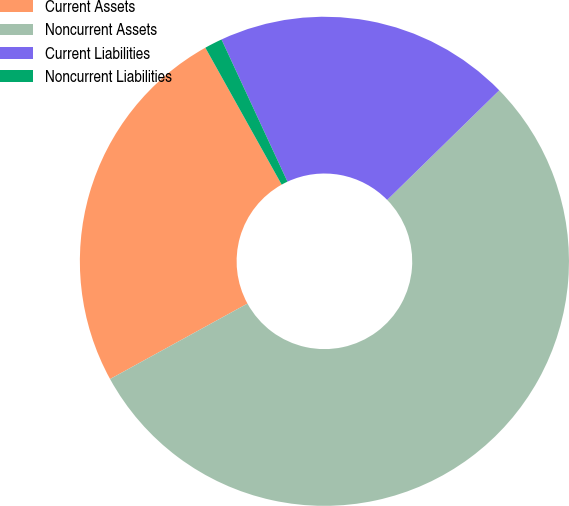Convert chart. <chart><loc_0><loc_0><loc_500><loc_500><pie_chart><fcel>Current Assets<fcel>Noncurrent Assets<fcel>Current Liabilities<fcel>Noncurrent Liabilities<nl><fcel>24.9%<fcel>54.33%<fcel>19.59%<fcel>1.18%<nl></chart> 